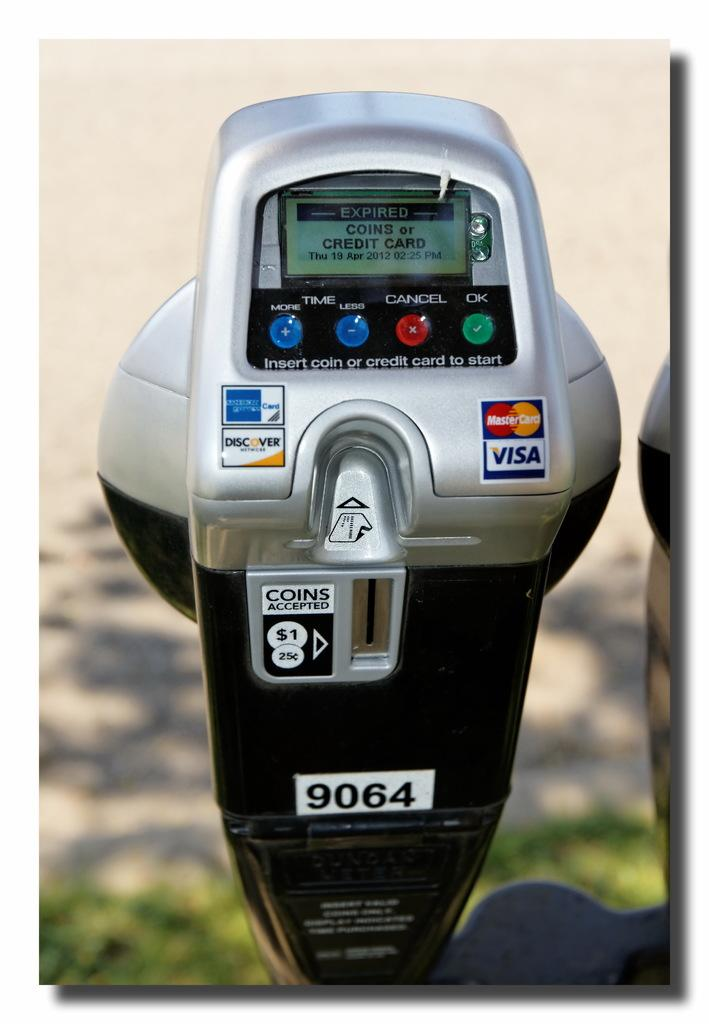<image>
Share a concise interpretation of the image provided. A Parking Payment Machine says it's expired but excepts coins, mastercard, and visa. 